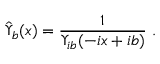Convert formula to latex. <formula><loc_0><loc_0><loc_500><loc_500>{ \hat { \Upsilon } } _ { b } ( x ) = { \frac { 1 } { \Upsilon _ { i b } ( - i x + i b ) } } \ .</formula> 